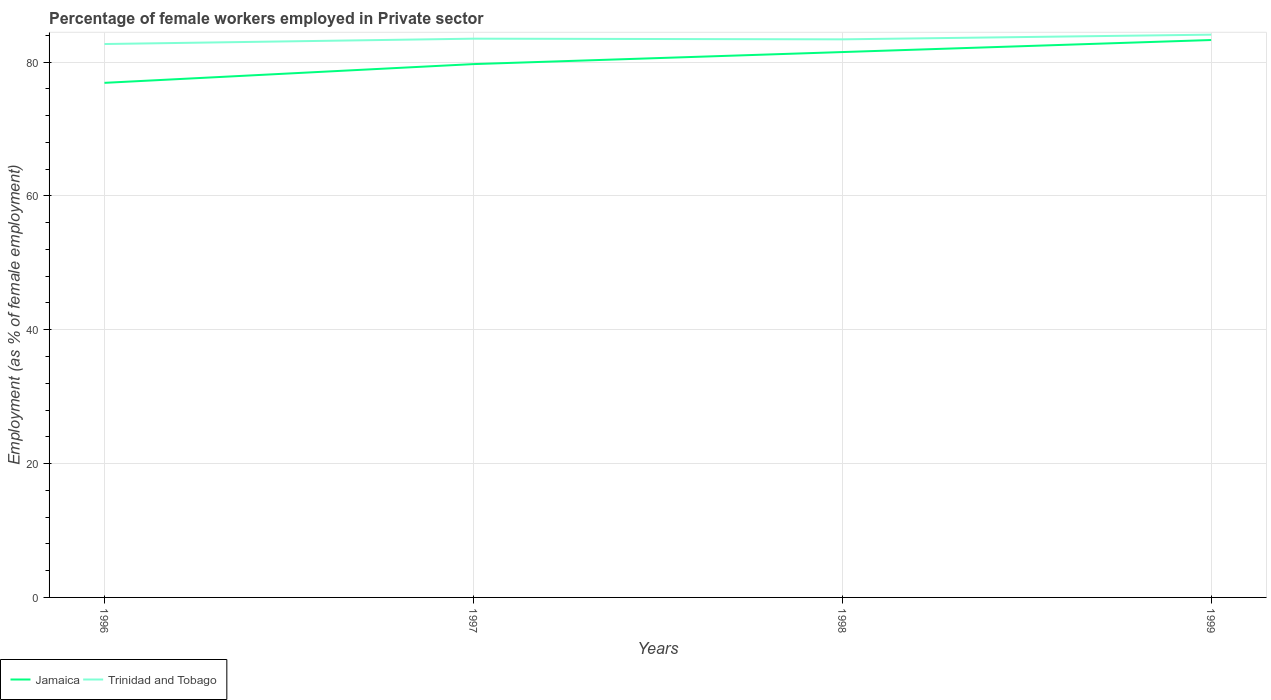Is the number of lines equal to the number of legend labels?
Offer a very short reply. Yes. Across all years, what is the maximum percentage of females employed in Private sector in Trinidad and Tobago?
Provide a succinct answer. 82.7. In which year was the percentage of females employed in Private sector in Trinidad and Tobago maximum?
Your answer should be very brief. 1996. What is the total percentage of females employed in Private sector in Jamaica in the graph?
Provide a succinct answer. -3.6. What is the difference between the highest and the second highest percentage of females employed in Private sector in Trinidad and Tobago?
Provide a succinct answer. 1.4. What is the difference between the highest and the lowest percentage of females employed in Private sector in Jamaica?
Ensure brevity in your answer.  2. How many years are there in the graph?
Give a very brief answer. 4. Are the values on the major ticks of Y-axis written in scientific E-notation?
Your answer should be very brief. No. Does the graph contain any zero values?
Make the answer very short. No. How many legend labels are there?
Your response must be concise. 2. How are the legend labels stacked?
Ensure brevity in your answer.  Horizontal. What is the title of the graph?
Ensure brevity in your answer.  Percentage of female workers employed in Private sector. What is the label or title of the Y-axis?
Offer a terse response. Employment (as % of female employment). What is the Employment (as % of female employment) of Jamaica in 1996?
Offer a very short reply. 76.9. What is the Employment (as % of female employment) in Trinidad and Tobago in 1996?
Your answer should be compact. 82.7. What is the Employment (as % of female employment) in Jamaica in 1997?
Make the answer very short. 79.7. What is the Employment (as % of female employment) in Trinidad and Tobago in 1997?
Your response must be concise. 83.5. What is the Employment (as % of female employment) in Jamaica in 1998?
Ensure brevity in your answer.  81.5. What is the Employment (as % of female employment) of Trinidad and Tobago in 1998?
Provide a succinct answer. 83.4. What is the Employment (as % of female employment) in Jamaica in 1999?
Ensure brevity in your answer.  83.3. What is the Employment (as % of female employment) in Trinidad and Tobago in 1999?
Ensure brevity in your answer.  84.1. Across all years, what is the maximum Employment (as % of female employment) in Jamaica?
Give a very brief answer. 83.3. Across all years, what is the maximum Employment (as % of female employment) in Trinidad and Tobago?
Ensure brevity in your answer.  84.1. Across all years, what is the minimum Employment (as % of female employment) in Jamaica?
Offer a terse response. 76.9. Across all years, what is the minimum Employment (as % of female employment) in Trinidad and Tobago?
Provide a succinct answer. 82.7. What is the total Employment (as % of female employment) in Jamaica in the graph?
Keep it short and to the point. 321.4. What is the total Employment (as % of female employment) in Trinidad and Tobago in the graph?
Give a very brief answer. 333.7. What is the difference between the Employment (as % of female employment) of Jamaica in 1996 and that in 1997?
Make the answer very short. -2.8. What is the difference between the Employment (as % of female employment) in Trinidad and Tobago in 1996 and that in 1999?
Provide a short and direct response. -1.4. What is the difference between the Employment (as % of female employment) in Jamaica in 1997 and that in 1998?
Offer a terse response. -1.8. What is the difference between the Employment (as % of female employment) of Jamaica in 1998 and that in 1999?
Provide a short and direct response. -1.8. What is the difference between the Employment (as % of female employment) of Trinidad and Tobago in 1998 and that in 1999?
Offer a terse response. -0.7. What is the difference between the Employment (as % of female employment) of Jamaica in 1996 and the Employment (as % of female employment) of Trinidad and Tobago in 1997?
Give a very brief answer. -6.6. What is the difference between the Employment (as % of female employment) in Jamaica in 1996 and the Employment (as % of female employment) in Trinidad and Tobago in 1998?
Make the answer very short. -6.5. What is the difference between the Employment (as % of female employment) in Jamaica in 1996 and the Employment (as % of female employment) in Trinidad and Tobago in 1999?
Provide a succinct answer. -7.2. What is the difference between the Employment (as % of female employment) of Jamaica in 1997 and the Employment (as % of female employment) of Trinidad and Tobago in 1998?
Provide a short and direct response. -3.7. What is the difference between the Employment (as % of female employment) in Jamaica in 1997 and the Employment (as % of female employment) in Trinidad and Tobago in 1999?
Provide a succinct answer. -4.4. What is the difference between the Employment (as % of female employment) of Jamaica in 1998 and the Employment (as % of female employment) of Trinidad and Tobago in 1999?
Your response must be concise. -2.6. What is the average Employment (as % of female employment) of Jamaica per year?
Make the answer very short. 80.35. What is the average Employment (as % of female employment) of Trinidad and Tobago per year?
Your response must be concise. 83.42. In the year 1996, what is the difference between the Employment (as % of female employment) in Jamaica and Employment (as % of female employment) in Trinidad and Tobago?
Ensure brevity in your answer.  -5.8. In the year 1997, what is the difference between the Employment (as % of female employment) of Jamaica and Employment (as % of female employment) of Trinidad and Tobago?
Provide a short and direct response. -3.8. What is the ratio of the Employment (as % of female employment) in Jamaica in 1996 to that in 1997?
Your answer should be very brief. 0.96. What is the ratio of the Employment (as % of female employment) in Trinidad and Tobago in 1996 to that in 1997?
Provide a short and direct response. 0.99. What is the ratio of the Employment (as % of female employment) of Jamaica in 1996 to that in 1998?
Provide a succinct answer. 0.94. What is the ratio of the Employment (as % of female employment) of Jamaica in 1996 to that in 1999?
Offer a very short reply. 0.92. What is the ratio of the Employment (as % of female employment) in Trinidad and Tobago in 1996 to that in 1999?
Your answer should be compact. 0.98. What is the ratio of the Employment (as % of female employment) of Jamaica in 1997 to that in 1998?
Ensure brevity in your answer.  0.98. What is the ratio of the Employment (as % of female employment) in Jamaica in 1997 to that in 1999?
Give a very brief answer. 0.96. What is the ratio of the Employment (as % of female employment) of Jamaica in 1998 to that in 1999?
Make the answer very short. 0.98. What is the ratio of the Employment (as % of female employment) of Trinidad and Tobago in 1998 to that in 1999?
Offer a terse response. 0.99. What is the difference between the highest and the second highest Employment (as % of female employment) of Trinidad and Tobago?
Offer a very short reply. 0.6. 